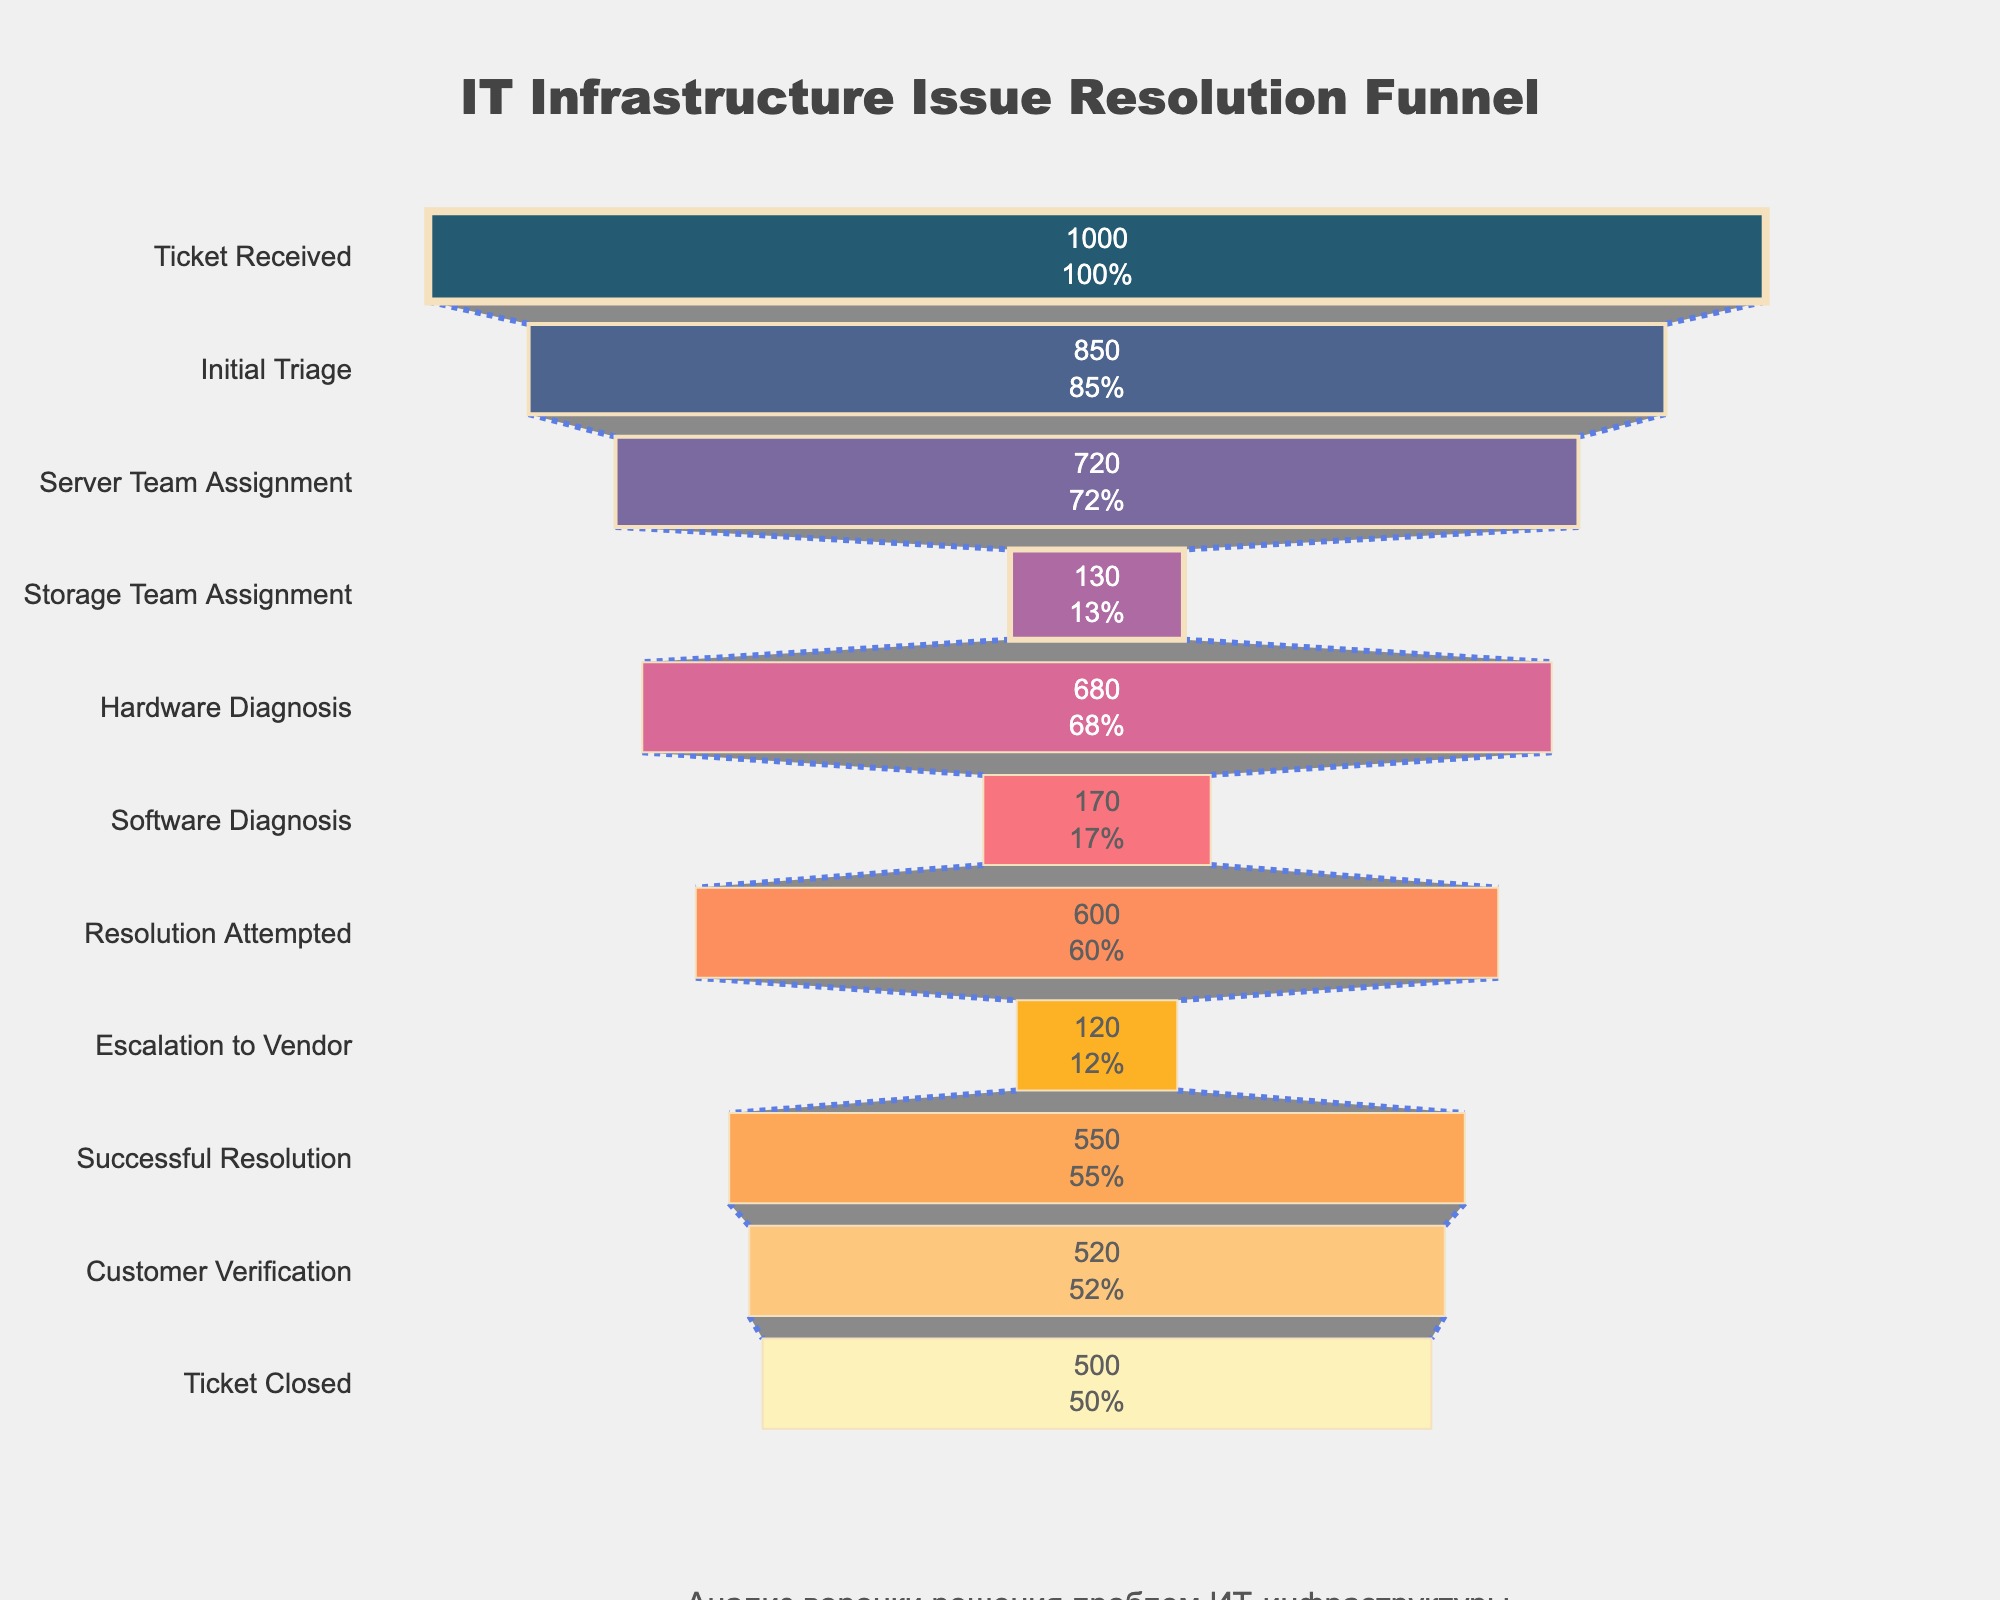What is the title of the funnel chart? The title is located at the top center of the figure and it reads "IT Infrastructure Issue Resolution Funnel".
Answer: IT Infrastructure Issue Resolution Funnel What stage has the highest count of tickets? The highest count of tickets is indicated by the longest bar in the funnel chart, which corresponds to the first stage "Ticket Received" with a count of 1000.
Answer: Ticket Received How many tickets were closed at the final stage? The count of tickets at the final stage "Ticket Closed" is given in the last bar of the funnel chart, which is 500.
Answer: 500 Which stage experienced the largest drop in ticket count? By comparing the differences between consecutive stages, the largest drop is observed between "Server Team Assignment" (720) and "Storage Team Assignment" (130), a reduction of 590 tickets.
Answer: Storage Team Assignment What percentage of the initial tickets were successfully resolved? The percentage of successfully resolved tickets can be calculated by dividing the count at "Successful Resolution" (550) by the initial count "Ticket Received" (1000) and then multiplying by 100: (550 / 1000) * 100 = 55%.
Answer: 55% At what stage do we see the smallest number of tickets before resolution attempts? The smallest number of tickets before resolution attempts can be found at "Storage Team Assignment" with a count of 130 tickets.
Answer: Storage Team Assignment How many tickets were escalated to the vendor? The count of tickets escalated to the vendor is given at the stage "Escalation to Vendor," which is 120.
Answer: 120 Compare the number of tickets at the "Resolution Attempted" stage to the "Successful Resolution" stage. The number of tickets at "Resolution Attempted" is 600, while at "Successful Resolution" the count is 550. These counts can be directly read from the corresponding bars on the chart.
Answer: Resolution Attempted: 600, Successful Resolution: 550 What is the difference in ticket count between "Hardware Diagnosis" and "Software Diagnosis"? The difference can be calculated by subtracting the count at "Software Diagnosis" (170) from the count at "Hardware Diagnosis" (680): 680 - 170 = 510.
Answer: 510 What color is used for the "Initial Triage" stage? The color used for the "Initial Triage" stage is shown by the second bar from the top, which is a shade of blue.
Answer: A shade of blue 